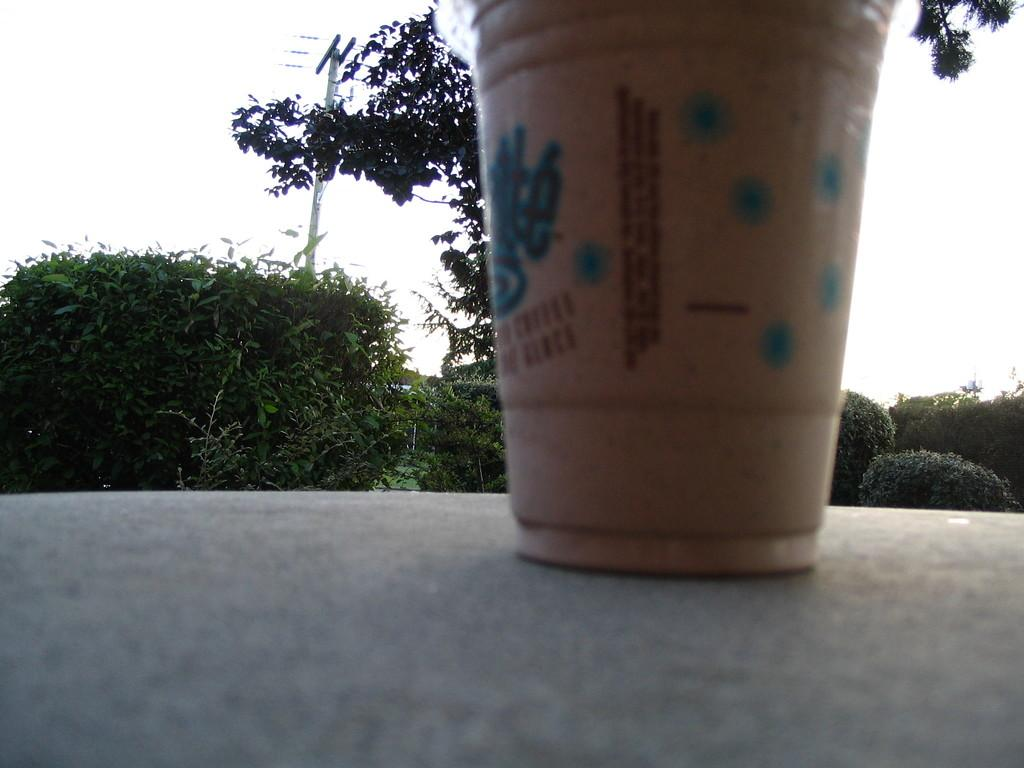What object is placed on the floor in the image? There is a cup on the floor in the image. What can be seen in the background of the image? There are plants in the background of the image. What structure is located in the middle of the image? There is an electric pole in the middle of the image. What is visible at the top of the image? The sky is visible at the top of the image. How many scales can be seen on the cup in the image? There are no scales present on the cup in the image. Is there a cellar visible in the image? There is no cellar present in the image. 